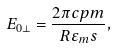<formula> <loc_0><loc_0><loc_500><loc_500>E _ { 0 \perp } = \frac { 2 \pi c p m } { R \varepsilon _ { m } s } ,</formula> 